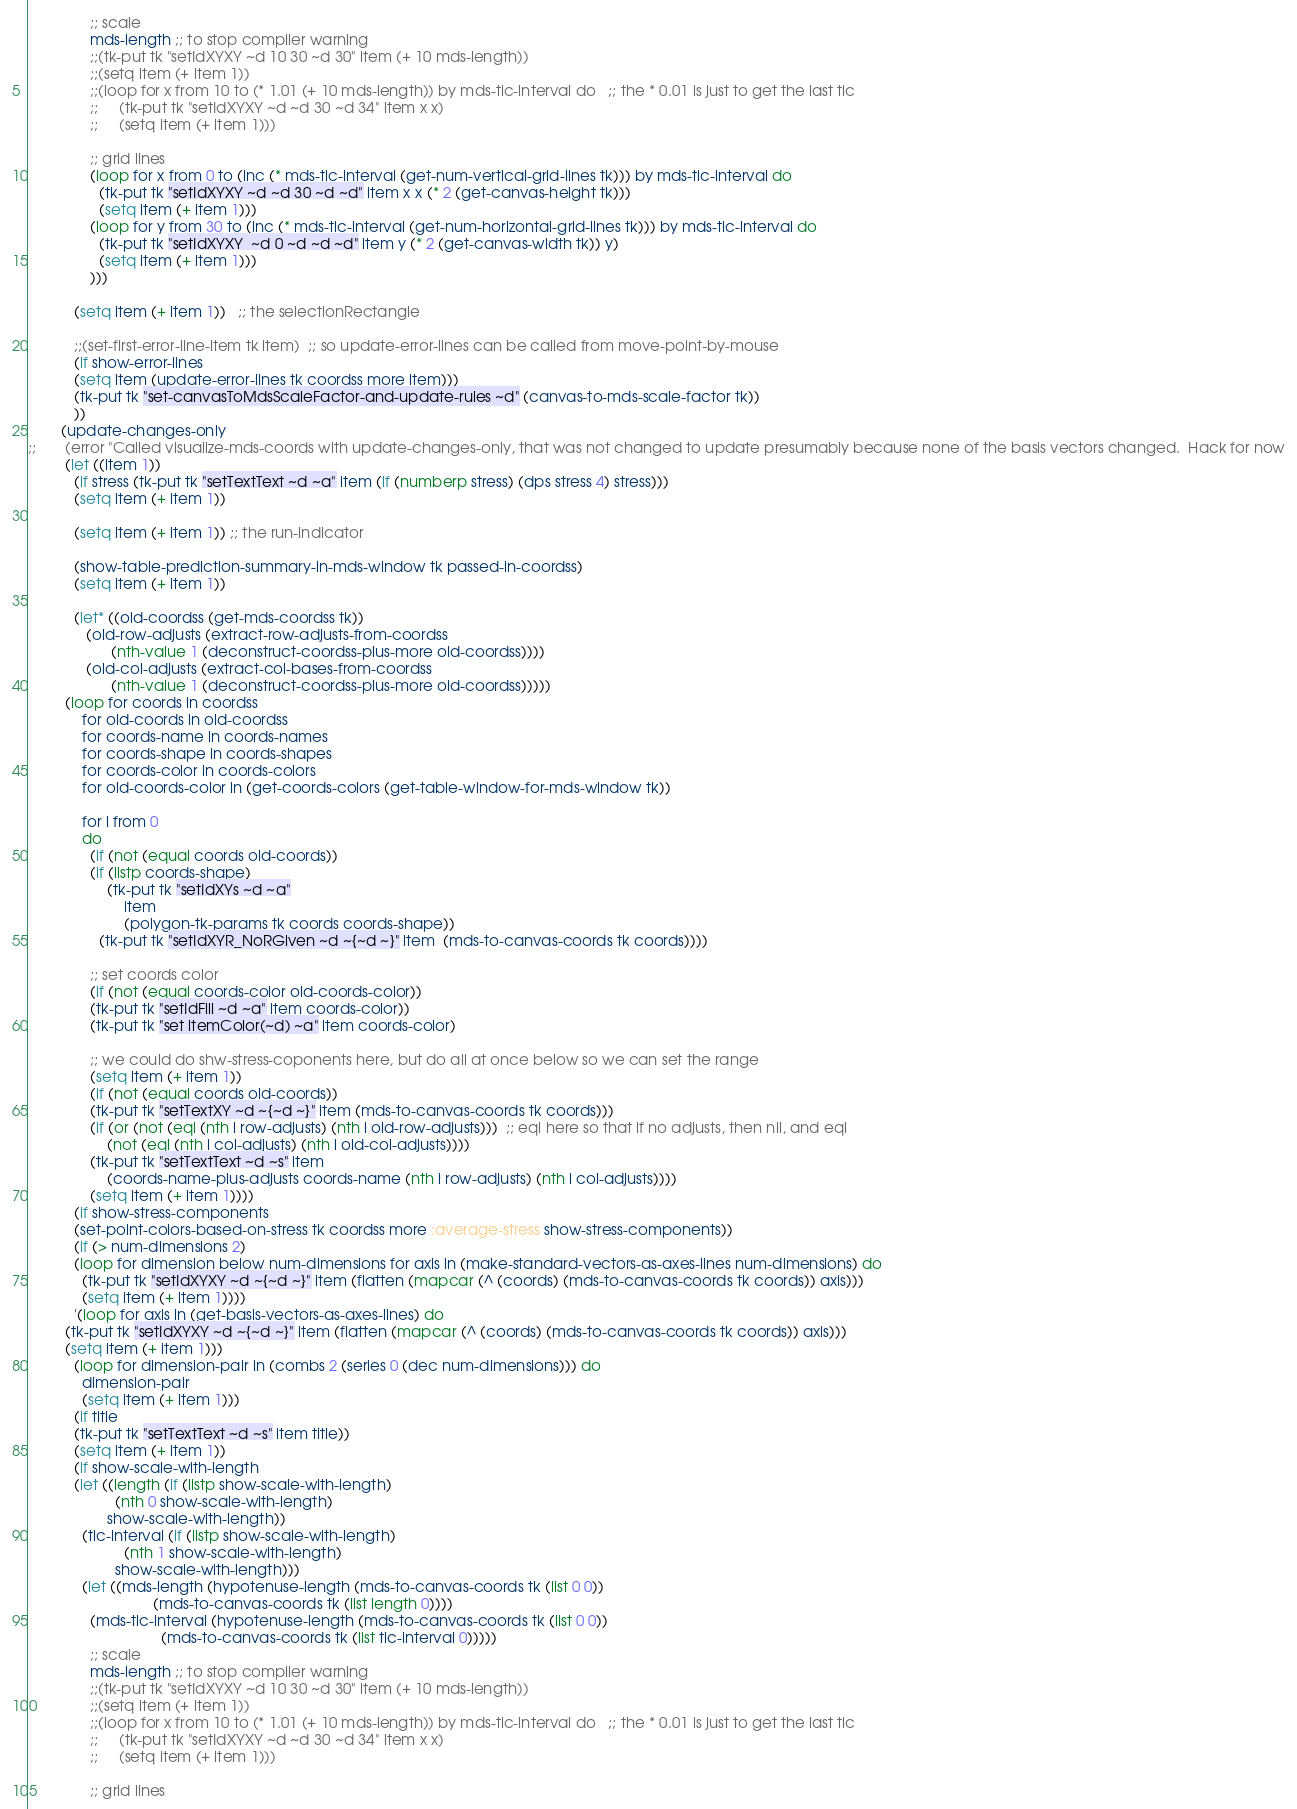<code> <loc_0><loc_0><loc_500><loc_500><_Lisp_>
		       ;; scale
		       mds-length ;; to stop compiler warning
		       ;;(tk-put tk "setIdXYXY ~d 10 30 ~d 30" item (+ 10 mds-length))
		       ;;(setq item (+ item 1))
		       ;;(loop for x from 10 to (* 1.01 (+ 10 mds-length)) by mds-tic-interval do   ;; the * 0.01 is just to get the last tic
		       ;;     (tk-put tk "setIdXYXY ~d ~d 30 ~d 34" item x x)
		       ;;     (setq item (+ item 1)))
		       
		       ;; grid lines
		       (loop for x from 0 to (inc (* mds-tic-interval (get-num-vertical-grid-lines tk))) by mds-tic-interval do
			     (tk-put tk "setIdXYXY ~d ~d 30 ~d ~d" item x x (* 2 (get-canvas-height tk)))
			     (setq item (+ item 1)))
		       (loop for y from 30 to (inc (* mds-tic-interval (get-num-horizontal-grid-lines tk))) by mds-tic-interval do
			     (tk-put tk "setIdXYXY  ~d 0 ~d ~d ~d" item y (* 2 (get-canvas-width tk)) y)
			     (setq item (+ item 1)))
		       )))

	       (setq item (+ item 1))   ;; the selectionRectangle

	       ;;(set-first-error-line-item tk item)  ;; so update-error-lines can be called from move-point-by-mouse
	       (if show-error-lines
		   (setq item (update-error-lines tk coordss more item)))
	       (tk-put tk "set-canvasToMdsScaleFactor-and-update-rules ~d" (canvas-to-mds-scale-factor tk))
	       ))
	    (update-changes-only 
;;	     (error "Called visualize-mds-coords with update-changes-only, that was not changed to update presumably because none of the basis vectors changed.  Hack for now
	     (let ((item 1))
	       (if stress (tk-put tk "setTextText ~d ~a" item (if (numberp stress) (dps stress 4) stress)))
	       (setq item (+ item 1))

	       (setq item (+ item 1)) ;; the run-indicator

	       (show-table-prediction-summary-in-mds-window tk passed-in-coordss)
	       (setq item (+ item 1))

	       (let* ((old-coordss (get-mds-coordss tk))
		      (old-row-adjusts (extract-row-adjusts-from-coordss 
					(nth-value 1 (deconstruct-coordss-plus-more old-coordss))))
		      (old-col-adjusts (extract-col-bases-from-coordss 
					(nth-value 1 (deconstruct-coordss-plus-more old-coordss)))))
		 (loop for coords in coordss 
		     for old-coords in old-coordss 
		     for coords-name in coords-names
		     for coords-shape in coords-shapes
		     for coords-color in coords-colors
		     for old-coords-color in (get-coords-colors (get-table-window-for-mds-window tk))

		     for i from 0
		     do
		       (if (not (equal coords old-coords))
			   (if (listp coords-shape)
			       (tk-put tk "setIdXYs ~d ~a" 
				       item
				       (polygon-tk-params tk coords coords-shape))
			     (tk-put tk "setIdXYR_NoRGiven ~d ~{~d ~}" item  (mds-to-canvas-coords tk coords))))

		       ;; set coords color
		       (if (not (equal coords-color old-coords-color))
			   (tk-put tk "setIdFill ~d ~a" item coords-color))
		       (tk-put tk "set itemColor(~d) ~a" item coords-color)

		       ;; we could do shw-stress-coponents here, but do all at once below so we can set the range
		       (setq item (+ item 1))
		       (if (not (equal coords old-coords))
			   (tk-put tk "setTextXY ~d ~{~d ~}" item (mds-to-canvas-coords tk coords)))
		       (if (or (not (eql (nth i row-adjusts) (nth i old-row-adjusts)))  ;; eql here so that if no adjusts, then nil, and eql
			       (not (eql (nth i col-adjusts) (nth i old-col-adjusts))))
			   (tk-put tk "setTextText ~d ~s" item 
				   (coords-name-plus-adjusts coords-name (nth i row-adjusts) (nth i col-adjusts))))
		       (setq item (+ item 1))))
	       (if show-stress-components
		   (set-point-colors-based-on-stress tk coordss more :average-stress show-stress-components))
	       (if (> num-dimensions 2)
		   (loop for dimension below num-dimensions for axis in (make-standard-vectors-as-axes-lines num-dimensions) do
			 (tk-put tk "setIdXYXY ~d ~{~d ~}" item (flatten (mapcar (^ (coords) (mds-to-canvas-coords tk coords)) axis)))
			 (setq item (+ item 1))))
	       '(loop for axis in (get-basis-vectors-as-axes-lines) do
		 (tk-put tk "setIdXYXY ~d ~{~d ~}" item (flatten (mapcar (^ (coords) (mds-to-canvas-coords tk coords)) axis)))
		 (setq item (+ item 1)))
	       (loop for dimension-pair in (combs 2 (series 0 (dec num-dimensions))) do
		     dimension-pair
		     (setq item (+ item 1)))
	       (if title
		   (tk-put tk "setTextText ~d ~s" item title))
	       (setq item (+ item 1))
	       (if show-scale-with-length
		   (let ((length (if (listp show-scale-with-length)
				     (nth 0 show-scale-with-length)
				   show-scale-with-length))
			 (tic-interval (if (listp show-scale-with-length)
					   (nth 1 show-scale-with-length)
					 show-scale-with-length)))
		     (let ((mds-length (hypotenuse-length (mds-to-canvas-coords tk (list 0 0))
							  (mds-to-canvas-coords tk (list length 0))))
			   (mds-tic-interval (hypotenuse-length (mds-to-canvas-coords tk (list 0 0))
								(mds-to-canvas-coords tk (list tic-interval 0)))))
		       ;; scale
		       mds-length ;; to stop compiler warning
		       ;;(tk-put tk "setIdXYXY ~d 10 30 ~d 30" item (+ 10 mds-length))
		       ;;(setq item (+ item 1))
		       ;;(loop for x from 10 to (* 1.01 (+ 10 mds-length)) by mds-tic-interval do   ;; the * 0.01 is just to get the last tic
		       ;;     (tk-put tk "setIdXYXY ~d ~d 30 ~d 34" item x x)
		       ;;     (setq item (+ item 1)))
		       
		       ;; grid lines</code> 